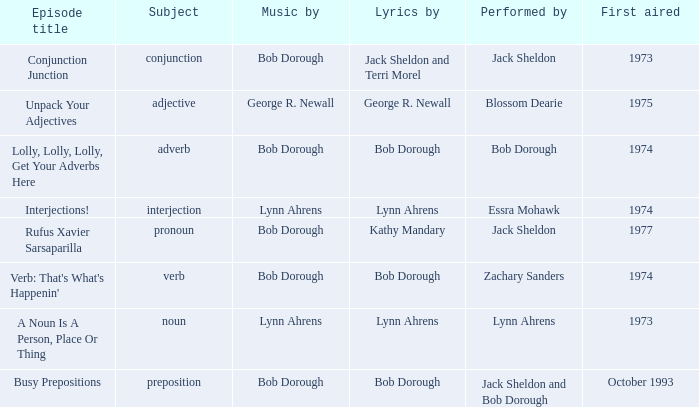Help me parse the entirety of this table. {'header': ['Episode title', 'Subject', 'Music by', 'Lyrics by', 'Performed by', 'First aired'], 'rows': [['Conjunction Junction', 'conjunction', 'Bob Dorough', 'Jack Sheldon and Terri Morel', 'Jack Sheldon', '1973'], ['Unpack Your Adjectives', 'adjective', 'George R. Newall', 'George R. Newall', 'Blossom Dearie', '1975'], ['Lolly, Lolly, Lolly, Get Your Adverbs Here', 'adverb', 'Bob Dorough', 'Bob Dorough', 'Bob Dorough', '1974'], ['Interjections!', 'interjection', 'Lynn Ahrens', 'Lynn Ahrens', 'Essra Mohawk', '1974'], ['Rufus Xavier Sarsaparilla', 'pronoun', 'Bob Dorough', 'Kathy Mandary', 'Jack Sheldon', '1977'], ["Verb: That's What's Happenin'", 'verb', 'Bob Dorough', 'Bob Dorough', 'Zachary Sanders', '1974'], ['A Noun Is A Person, Place Or Thing', 'noun', 'Lynn Ahrens', 'Lynn Ahrens', 'Lynn Ahrens', '1973'], ['Busy Prepositions', 'preposition', 'Bob Dorough', 'Bob Dorough', 'Jack Sheldon and Bob Dorough', 'October 1993']]} When pronoun is the subject what is the episode title? Rufus Xavier Sarsaparilla. 